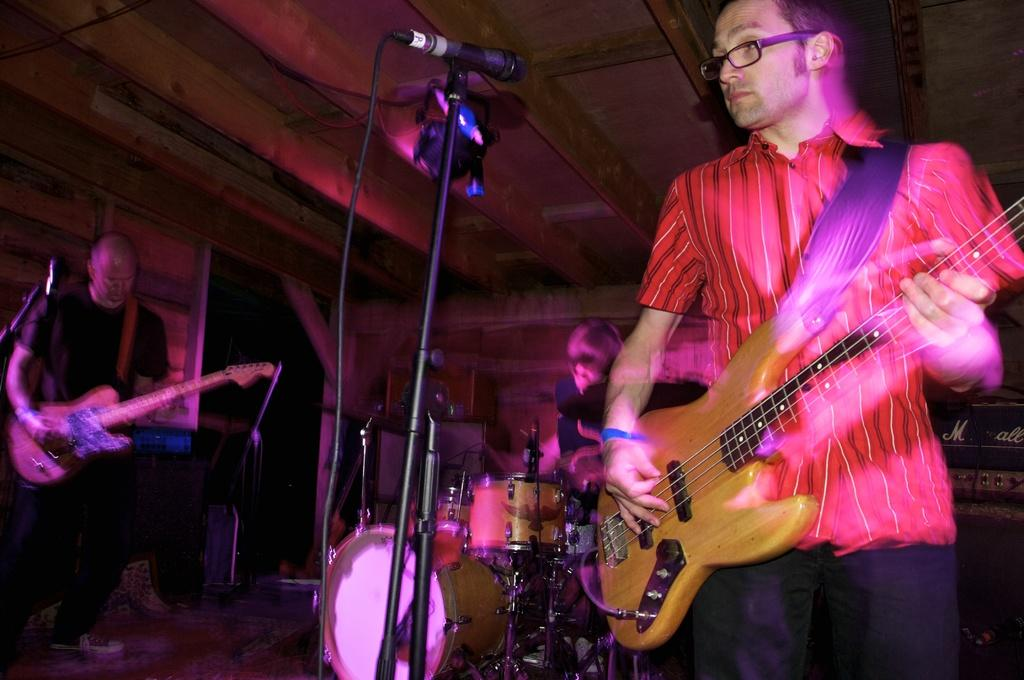What are the people in the image doing? There is a man standing and playing a guitar, another man sitting and playing a guitar, and another man sitting and playing drums in the image. How many people are playing musical instruments in the image? There are three people playing musical instruments in the image. What can be seen in the background of the image? There is a door visible in the background of the image. What type of chairs can be seen in the image? There are no chairs visible in the image. Can you describe the clouds in the image? There are no clouds visible in the image. 